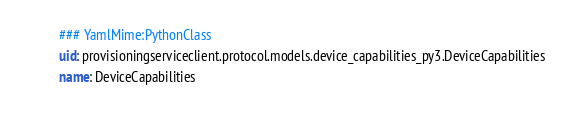<code> <loc_0><loc_0><loc_500><loc_500><_YAML_>### YamlMime:PythonClass
uid: provisioningserviceclient.protocol.models.device_capabilities_py3.DeviceCapabilities
name: DeviceCapabilities</code> 